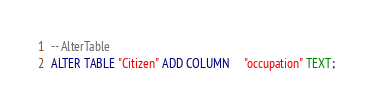<code> <loc_0><loc_0><loc_500><loc_500><_SQL_>-- AlterTable
ALTER TABLE "Citizen" ADD COLUMN     "occupation" TEXT;
</code> 